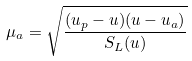Convert formula to latex. <formula><loc_0><loc_0><loc_500><loc_500>\mu _ { a } = \sqrt { \frac { ( u _ { p } - u ) ( u - u _ { a } ) } { S _ { L } ( u ) } }</formula> 